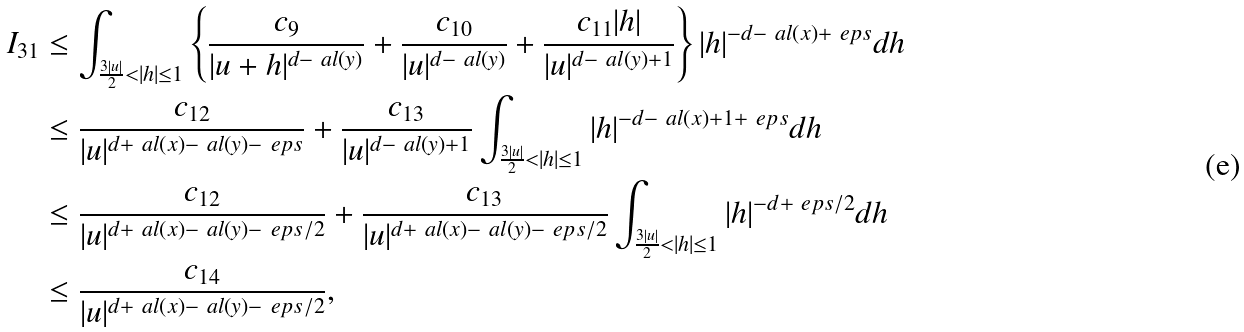<formula> <loc_0><loc_0><loc_500><loc_500>I _ { 3 1 } & \leq \int _ { \frac { 3 | u | } { 2 } < | h | \leq 1 } \left \{ \frac { c _ { 9 } } { | u + h | ^ { d - \ a l ( y ) } } + \frac { c _ { 1 0 } } { | u | ^ { d - \ a l ( y ) } } + \frac { c _ { 1 1 } | h | } { | u | ^ { d - \ a l ( y ) + 1 } } \right \} | h | ^ { - d - \ a l ( x ) + \ e p s } d h \\ & \leq \frac { c _ { 1 2 } } { | u | ^ { d + \ a l ( x ) - \ a l ( y ) - \ e p s } } + \frac { c _ { 1 3 } } { | u | ^ { d - \ a l ( y ) + 1 } } \int _ { \frac { 3 | u | } { 2 } < | h | \leq 1 } | h | ^ { - d - \ a l ( x ) + 1 + \ e p s } d h \\ & \leq \frac { c _ { 1 2 } } { | u | ^ { d + \ a l ( x ) - \ a l ( y ) - \ e p s / 2 } } + \frac { c _ { 1 3 } } { | u | ^ { d + \ a l ( x ) - \ a l ( y ) - \ e p s / 2 } } \int _ { \frac { 3 | u | } { 2 } < | h | \leq 1 } | h | ^ { - d + \ e p s / 2 } d h \\ & \leq \frac { c _ { 1 4 } } { | u | ^ { d + \ a l ( x ) - \ a l ( y ) - \ e p s / 2 } } ,</formula> 